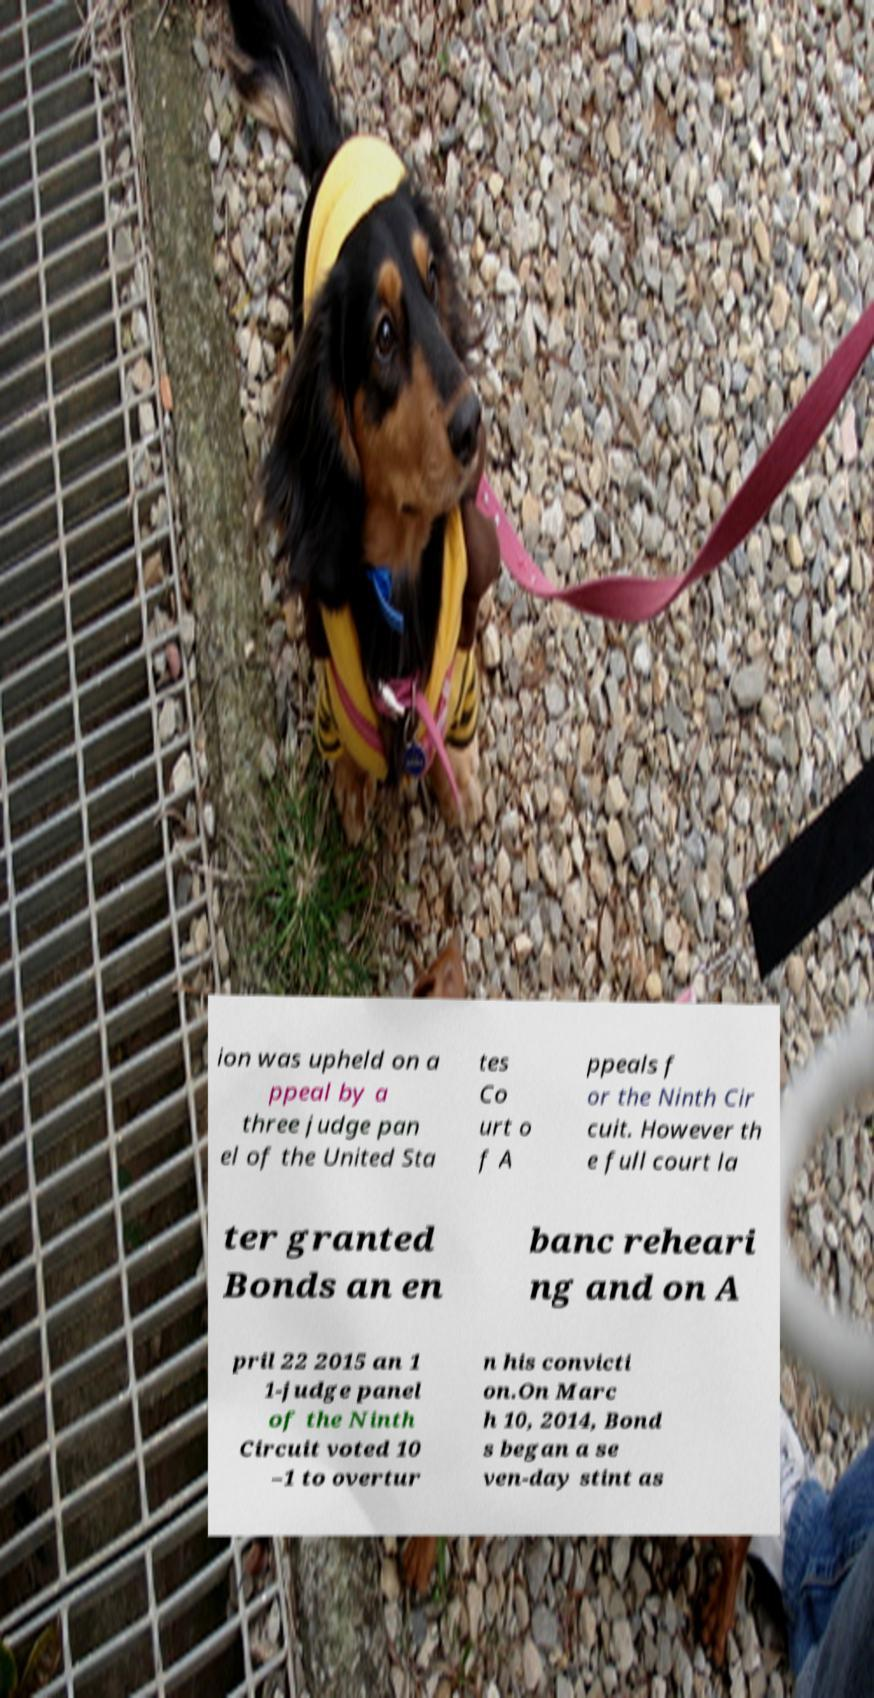I need the written content from this picture converted into text. Can you do that? ion was upheld on a ppeal by a three judge pan el of the United Sta tes Co urt o f A ppeals f or the Ninth Cir cuit. However th e full court la ter granted Bonds an en banc reheari ng and on A pril 22 2015 an 1 1-judge panel of the Ninth Circuit voted 10 –1 to overtur n his convicti on.On Marc h 10, 2014, Bond s began a se ven-day stint as 